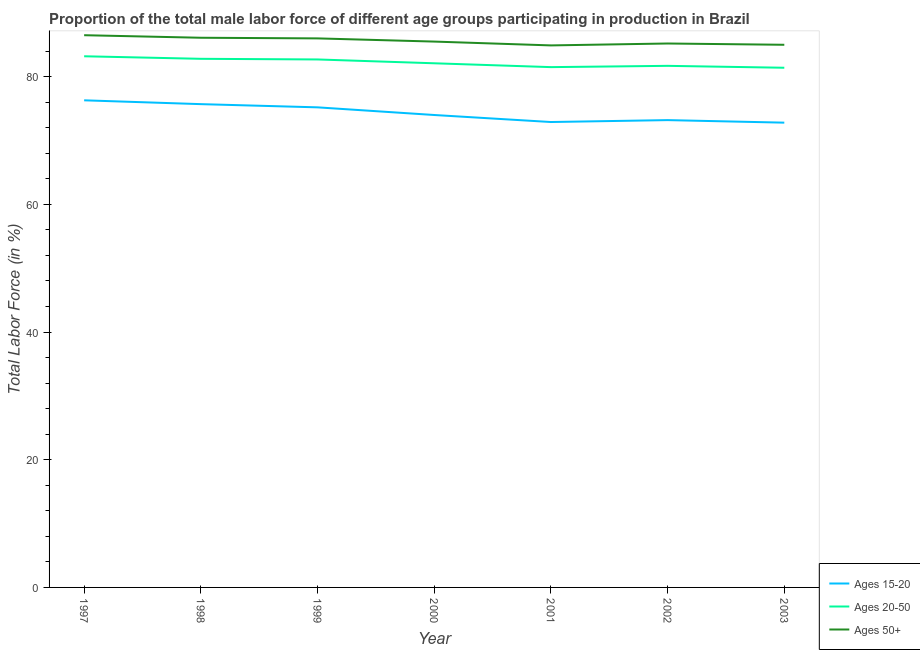Does the line corresponding to percentage of male labor force above age 50 intersect with the line corresponding to percentage of male labor force within the age group 20-50?
Ensure brevity in your answer.  No. What is the percentage of male labor force within the age group 15-20 in 2002?
Make the answer very short. 73.2. Across all years, what is the maximum percentage of male labor force within the age group 20-50?
Make the answer very short. 83.2. Across all years, what is the minimum percentage of male labor force above age 50?
Provide a short and direct response. 84.9. In which year was the percentage of male labor force above age 50 minimum?
Offer a very short reply. 2001. What is the total percentage of male labor force above age 50 in the graph?
Provide a short and direct response. 599.2. What is the difference between the percentage of male labor force within the age group 20-50 in 1997 and that in 1999?
Offer a terse response. 0.5. What is the difference between the percentage of male labor force within the age group 20-50 in 1999 and the percentage of male labor force within the age group 15-20 in 2001?
Your response must be concise. 9.8. What is the average percentage of male labor force above age 50 per year?
Make the answer very short. 85.6. What is the ratio of the percentage of male labor force above age 50 in 1998 to that in 2002?
Make the answer very short. 1.01. Is the difference between the percentage of male labor force above age 50 in 1998 and 2003 greater than the difference between the percentage of male labor force within the age group 15-20 in 1998 and 2003?
Your answer should be compact. No. What is the difference between the highest and the second highest percentage of male labor force above age 50?
Offer a very short reply. 0.4. What is the difference between the highest and the lowest percentage of male labor force within the age group 20-50?
Offer a terse response. 1.8. In how many years, is the percentage of male labor force above age 50 greater than the average percentage of male labor force above age 50 taken over all years?
Make the answer very short. 3. Is the sum of the percentage of male labor force within the age group 15-20 in 2002 and 2003 greater than the maximum percentage of male labor force above age 50 across all years?
Provide a short and direct response. Yes. Does the percentage of male labor force above age 50 monotonically increase over the years?
Your response must be concise. No. What is the difference between two consecutive major ticks on the Y-axis?
Make the answer very short. 20. Are the values on the major ticks of Y-axis written in scientific E-notation?
Give a very brief answer. No. How many legend labels are there?
Ensure brevity in your answer.  3. How are the legend labels stacked?
Keep it short and to the point. Vertical. What is the title of the graph?
Keep it short and to the point. Proportion of the total male labor force of different age groups participating in production in Brazil. Does "Labor Tax" appear as one of the legend labels in the graph?
Offer a very short reply. No. What is the Total Labor Force (in %) of Ages 15-20 in 1997?
Provide a succinct answer. 76.3. What is the Total Labor Force (in %) of Ages 20-50 in 1997?
Ensure brevity in your answer.  83.2. What is the Total Labor Force (in %) of Ages 50+ in 1997?
Give a very brief answer. 86.5. What is the Total Labor Force (in %) in Ages 15-20 in 1998?
Give a very brief answer. 75.7. What is the Total Labor Force (in %) in Ages 20-50 in 1998?
Provide a succinct answer. 82.8. What is the Total Labor Force (in %) of Ages 50+ in 1998?
Your answer should be compact. 86.1. What is the Total Labor Force (in %) in Ages 15-20 in 1999?
Your answer should be compact. 75.2. What is the Total Labor Force (in %) in Ages 20-50 in 1999?
Provide a succinct answer. 82.7. What is the Total Labor Force (in %) of Ages 15-20 in 2000?
Your response must be concise. 74. What is the Total Labor Force (in %) in Ages 20-50 in 2000?
Offer a terse response. 82.1. What is the Total Labor Force (in %) of Ages 50+ in 2000?
Provide a short and direct response. 85.5. What is the Total Labor Force (in %) in Ages 15-20 in 2001?
Give a very brief answer. 72.9. What is the Total Labor Force (in %) of Ages 20-50 in 2001?
Your response must be concise. 81.5. What is the Total Labor Force (in %) of Ages 50+ in 2001?
Provide a short and direct response. 84.9. What is the Total Labor Force (in %) in Ages 15-20 in 2002?
Offer a very short reply. 73.2. What is the Total Labor Force (in %) of Ages 20-50 in 2002?
Ensure brevity in your answer.  81.7. What is the Total Labor Force (in %) in Ages 50+ in 2002?
Provide a succinct answer. 85.2. What is the Total Labor Force (in %) in Ages 15-20 in 2003?
Your response must be concise. 72.8. What is the Total Labor Force (in %) in Ages 20-50 in 2003?
Offer a very short reply. 81.4. What is the Total Labor Force (in %) of Ages 50+ in 2003?
Provide a succinct answer. 85. Across all years, what is the maximum Total Labor Force (in %) of Ages 15-20?
Offer a very short reply. 76.3. Across all years, what is the maximum Total Labor Force (in %) of Ages 20-50?
Provide a short and direct response. 83.2. Across all years, what is the maximum Total Labor Force (in %) in Ages 50+?
Give a very brief answer. 86.5. Across all years, what is the minimum Total Labor Force (in %) of Ages 15-20?
Ensure brevity in your answer.  72.8. Across all years, what is the minimum Total Labor Force (in %) in Ages 20-50?
Ensure brevity in your answer.  81.4. Across all years, what is the minimum Total Labor Force (in %) of Ages 50+?
Ensure brevity in your answer.  84.9. What is the total Total Labor Force (in %) in Ages 15-20 in the graph?
Your answer should be compact. 520.1. What is the total Total Labor Force (in %) in Ages 20-50 in the graph?
Provide a short and direct response. 575.4. What is the total Total Labor Force (in %) in Ages 50+ in the graph?
Your answer should be compact. 599.2. What is the difference between the Total Labor Force (in %) in Ages 15-20 in 1997 and that in 1998?
Provide a short and direct response. 0.6. What is the difference between the Total Labor Force (in %) in Ages 50+ in 1997 and that in 1998?
Offer a very short reply. 0.4. What is the difference between the Total Labor Force (in %) of Ages 20-50 in 1997 and that in 1999?
Give a very brief answer. 0.5. What is the difference between the Total Labor Force (in %) in Ages 50+ in 1997 and that in 1999?
Provide a short and direct response. 0.5. What is the difference between the Total Labor Force (in %) of Ages 15-20 in 1997 and that in 2000?
Keep it short and to the point. 2.3. What is the difference between the Total Labor Force (in %) of Ages 15-20 in 1997 and that in 2001?
Offer a terse response. 3.4. What is the difference between the Total Labor Force (in %) of Ages 50+ in 1997 and that in 2001?
Your answer should be very brief. 1.6. What is the difference between the Total Labor Force (in %) in Ages 15-20 in 1997 and that in 2002?
Provide a short and direct response. 3.1. What is the difference between the Total Labor Force (in %) of Ages 20-50 in 1997 and that in 2002?
Offer a terse response. 1.5. What is the difference between the Total Labor Force (in %) of Ages 50+ in 1997 and that in 2002?
Offer a very short reply. 1.3. What is the difference between the Total Labor Force (in %) in Ages 50+ in 1998 and that in 2000?
Your answer should be compact. 0.6. What is the difference between the Total Labor Force (in %) in Ages 20-50 in 1998 and that in 2001?
Provide a succinct answer. 1.3. What is the difference between the Total Labor Force (in %) of Ages 50+ in 1998 and that in 2001?
Give a very brief answer. 1.2. What is the difference between the Total Labor Force (in %) of Ages 15-20 in 1998 and that in 2002?
Make the answer very short. 2.5. What is the difference between the Total Labor Force (in %) of Ages 20-50 in 1998 and that in 2002?
Provide a short and direct response. 1.1. What is the difference between the Total Labor Force (in %) in Ages 20-50 in 1998 and that in 2003?
Ensure brevity in your answer.  1.4. What is the difference between the Total Labor Force (in %) of Ages 50+ in 1998 and that in 2003?
Make the answer very short. 1.1. What is the difference between the Total Labor Force (in %) in Ages 20-50 in 1999 and that in 2000?
Offer a terse response. 0.6. What is the difference between the Total Labor Force (in %) of Ages 50+ in 1999 and that in 2000?
Give a very brief answer. 0.5. What is the difference between the Total Labor Force (in %) in Ages 20-50 in 1999 and that in 2001?
Your response must be concise. 1.2. What is the difference between the Total Labor Force (in %) in Ages 50+ in 1999 and that in 2001?
Your answer should be very brief. 1.1. What is the difference between the Total Labor Force (in %) of Ages 20-50 in 1999 and that in 2002?
Give a very brief answer. 1. What is the difference between the Total Labor Force (in %) of Ages 50+ in 1999 and that in 2002?
Make the answer very short. 0.8. What is the difference between the Total Labor Force (in %) of Ages 15-20 in 2000 and that in 2001?
Your answer should be very brief. 1.1. What is the difference between the Total Labor Force (in %) in Ages 20-50 in 2000 and that in 2001?
Provide a succinct answer. 0.6. What is the difference between the Total Labor Force (in %) of Ages 50+ in 2000 and that in 2001?
Offer a very short reply. 0.6. What is the difference between the Total Labor Force (in %) of Ages 15-20 in 2000 and that in 2002?
Your answer should be very brief. 0.8. What is the difference between the Total Labor Force (in %) of Ages 50+ in 2000 and that in 2002?
Keep it short and to the point. 0.3. What is the difference between the Total Labor Force (in %) in Ages 15-20 in 2000 and that in 2003?
Offer a terse response. 1.2. What is the difference between the Total Labor Force (in %) of Ages 50+ in 2000 and that in 2003?
Make the answer very short. 0.5. What is the difference between the Total Labor Force (in %) in Ages 50+ in 2001 and that in 2002?
Your answer should be compact. -0.3. What is the difference between the Total Labor Force (in %) in Ages 20-50 in 2001 and that in 2003?
Ensure brevity in your answer.  0.1. What is the difference between the Total Labor Force (in %) of Ages 50+ in 2001 and that in 2003?
Offer a very short reply. -0.1. What is the difference between the Total Labor Force (in %) of Ages 20-50 in 2002 and that in 2003?
Keep it short and to the point. 0.3. What is the difference between the Total Labor Force (in %) of Ages 15-20 in 1997 and the Total Labor Force (in %) of Ages 20-50 in 1998?
Your answer should be compact. -6.5. What is the difference between the Total Labor Force (in %) of Ages 20-50 in 1997 and the Total Labor Force (in %) of Ages 50+ in 1998?
Your answer should be very brief. -2.9. What is the difference between the Total Labor Force (in %) of Ages 15-20 in 1997 and the Total Labor Force (in %) of Ages 20-50 in 1999?
Ensure brevity in your answer.  -6.4. What is the difference between the Total Labor Force (in %) in Ages 15-20 in 1997 and the Total Labor Force (in %) in Ages 50+ in 1999?
Provide a short and direct response. -9.7. What is the difference between the Total Labor Force (in %) in Ages 20-50 in 1997 and the Total Labor Force (in %) in Ages 50+ in 1999?
Offer a very short reply. -2.8. What is the difference between the Total Labor Force (in %) of Ages 20-50 in 1997 and the Total Labor Force (in %) of Ages 50+ in 2000?
Make the answer very short. -2.3. What is the difference between the Total Labor Force (in %) of Ages 15-20 in 1997 and the Total Labor Force (in %) of Ages 20-50 in 2002?
Your response must be concise. -5.4. What is the difference between the Total Labor Force (in %) in Ages 15-20 in 1997 and the Total Labor Force (in %) in Ages 50+ in 2002?
Give a very brief answer. -8.9. What is the difference between the Total Labor Force (in %) of Ages 20-50 in 1997 and the Total Labor Force (in %) of Ages 50+ in 2002?
Your answer should be compact. -2. What is the difference between the Total Labor Force (in %) of Ages 15-20 in 1997 and the Total Labor Force (in %) of Ages 20-50 in 2003?
Offer a very short reply. -5.1. What is the difference between the Total Labor Force (in %) in Ages 15-20 in 1997 and the Total Labor Force (in %) in Ages 50+ in 2003?
Your response must be concise. -8.7. What is the difference between the Total Labor Force (in %) of Ages 20-50 in 1997 and the Total Labor Force (in %) of Ages 50+ in 2003?
Offer a terse response. -1.8. What is the difference between the Total Labor Force (in %) of Ages 15-20 in 1998 and the Total Labor Force (in %) of Ages 20-50 in 1999?
Provide a short and direct response. -7. What is the difference between the Total Labor Force (in %) in Ages 15-20 in 1998 and the Total Labor Force (in %) in Ages 50+ in 1999?
Ensure brevity in your answer.  -10.3. What is the difference between the Total Labor Force (in %) of Ages 20-50 in 1998 and the Total Labor Force (in %) of Ages 50+ in 1999?
Provide a succinct answer. -3.2. What is the difference between the Total Labor Force (in %) of Ages 15-20 in 1998 and the Total Labor Force (in %) of Ages 20-50 in 2000?
Make the answer very short. -6.4. What is the difference between the Total Labor Force (in %) of Ages 15-20 in 1998 and the Total Labor Force (in %) of Ages 50+ in 2000?
Provide a succinct answer. -9.8. What is the difference between the Total Labor Force (in %) of Ages 15-20 in 1998 and the Total Labor Force (in %) of Ages 20-50 in 2001?
Make the answer very short. -5.8. What is the difference between the Total Labor Force (in %) of Ages 15-20 in 1998 and the Total Labor Force (in %) of Ages 50+ in 2001?
Ensure brevity in your answer.  -9.2. What is the difference between the Total Labor Force (in %) in Ages 20-50 in 1998 and the Total Labor Force (in %) in Ages 50+ in 2001?
Offer a terse response. -2.1. What is the difference between the Total Labor Force (in %) in Ages 15-20 in 1998 and the Total Labor Force (in %) in Ages 20-50 in 2003?
Your answer should be compact. -5.7. What is the difference between the Total Labor Force (in %) of Ages 20-50 in 1998 and the Total Labor Force (in %) of Ages 50+ in 2003?
Your answer should be very brief. -2.2. What is the difference between the Total Labor Force (in %) of Ages 15-20 in 1999 and the Total Labor Force (in %) of Ages 20-50 in 2000?
Provide a short and direct response. -6.9. What is the difference between the Total Labor Force (in %) in Ages 15-20 in 1999 and the Total Labor Force (in %) in Ages 50+ in 2000?
Offer a very short reply. -10.3. What is the difference between the Total Labor Force (in %) in Ages 15-20 in 1999 and the Total Labor Force (in %) in Ages 50+ in 2001?
Offer a terse response. -9.7. What is the difference between the Total Labor Force (in %) in Ages 20-50 in 1999 and the Total Labor Force (in %) in Ages 50+ in 2001?
Provide a succinct answer. -2.2. What is the difference between the Total Labor Force (in %) in Ages 15-20 in 1999 and the Total Labor Force (in %) in Ages 50+ in 2002?
Your answer should be very brief. -10. What is the difference between the Total Labor Force (in %) of Ages 20-50 in 1999 and the Total Labor Force (in %) of Ages 50+ in 2002?
Provide a succinct answer. -2.5. What is the difference between the Total Labor Force (in %) of Ages 15-20 in 1999 and the Total Labor Force (in %) of Ages 20-50 in 2003?
Provide a short and direct response. -6.2. What is the difference between the Total Labor Force (in %) of Ages 15-20 in 1999 and the Total Labor Force (in %) of Ages 50+ in 2003?
Your answer should be very brief. -9.8. What is the difference between the Total Labor Force (in %) in Ages 15-20 in 2000 and the Total Labor Force (in %) in Ages 50+ in 2001?
Keep it short and to the point. -10.9. What is the difference between the Total Labor Force (in %) in Ages 20-50 in 2000 and the Total Labor Force (in %) in Ages 50+ in 2001?
Your answer should be very brief. -2.8. What is the difference between the Total Labor Force (in %) in Ages 15-20 in 2000 and the Total Labor Force (in %) in Ages 20-50 in 2002?
Give a very brief answer. -7.7. What is the difference between the Total Labor Force (in %) in Ages 15-20 in 2000 and the Total Labor Force (in %) in Ages 50+ in 2002?
Give a very brief answer. -11.2. What is the difference between the Total Labor Force (in %) in Ages 20-50 in 2000 and the Total Labor Force (in %) in Ages 50+ in 2002?
Make the answer very short. -3.1. What is the difference between the Total Labor Force (in %) of Ages 20-50 in 2000 and the Total Labor Force (in %) of Ages 50+ in 2003?
Your response must be concise. -2.9. What is the difference between the Total Labor Force (in %) of Ages 15-20 in 2001 and the Total Labor Force (in %) of Ages 20-50 in 2002?
Your answer should be compact. -8.8. What is the difference between the Total Labor Force (in %) of Ages 15-20 in 2001 and the Total Labor Force (in %) of Ages 50+ in 2002?
Your response must be concise. -12.3. What is the difference between the Total Labor Force (in %) of Ages 15-20 in 2002 and the Total Labor Force (in %) of Ages 20-50 in 2003?
Provide a succinct answer. -8.2. What is the difference between the Total Labor Force (in %) in Ages 20-50 in 2002 and the Total Labor Force (in %) in Ages 50+ in 2003?
Your response must be concise. -3.3. What is the average Total Labor Force (in %) in Ages 15-20 per year?
Give a very brief answer. 74.3. What is the average Total Labor Force (in %) in Ages 20-50 per year?
Offer a very short reply. 82.2. What is the average Total Labor Force (in %) in Ages 50+ per year?
Your answer should be compact. 85.6. In the year 1997, what is the difference between the Total Labor Force (in %) in Ages 15-20 and Total Labor Force (in %) in Ages 20-50?
Your answer should be compact. -6.9. In the year 1997, what is the difference between the Total Labor Force (in %) in Ages 15-20 and Total Labor Force (in %) in Ages 50+?
Your response must be concise. -10.2. In the year 1997, what is the difference between the Total Labor Force (in %) in Ages 20-50 and Total Labor Force (in %) in Ages 50+?
Keep it short and to the point. -3.3. In the year 1998, what is the difference between the Total Labor Force (in %) of Ages 15-20 and Total Labor Force (in %) of Ages 20-50?
Offer a terse response. -7.1. In the year 1998, what is the difference between the Total Labor Force (in %) in Ages 15-20 and Total Labor Force (in %) in Ages 50+?
Offer a very short reply. -10.4. In the year 1998, what is the difference between the Total Labor Force (in %) of Ages 20-50 and Total Labor Force (in %) of Ages 50+?
Provide a short and direct response. -3.3. In the year 1999, what is the difference between the Total Labor Force (in %) in Ages 15-20 and Total Labor Force (in %) in Ages 20-50?
Offer a terse response. -7.5. In the year 1999, what is the difference between the Total Labor Force (in %) of Ages 15-20 and Total Labor Force (in %) of Ages 50+?
Keep it short and to the point. -10.8. In the year 1999, what is the difference between the Total Labor Force (in %) of Ages 20-50 and Total Labor Force (in %) of Ages 50+?
Offer a very short reply. -3.3. In the year 2000, what is the difference between the Total Labor Force (in %) of Ages 15-20 and Total Labor Force (in %) of Ages 50+?
Your answer should be very brief. -11.5. In the year 2000, what is the difference between the Total Labor Force (in %) of Ages 20-50 and Total Labor Force (in %) of Ages 50+?
Keep it short and to the point. -3.4. In the year 2001, what is the difference between the Total Labor Force (in %) in Ages 15-20 and Total Labor Force (in %) in Ages 20-50?
Make the answer very short. -8.6. In the year 2001, what is the difference between the Total Labor Force (in %) in Ages 20-50 and Total Labor Force (in %) in Ages 50+?
Your response must be concise. -3.4. In the year 2002, what is the difference between the Total Labor Force (in %) in Ages 20-50 and Total Labor Force (in %) in Ages 50+?
Offer a terse response. -3.5. In the year 2003, what is the difference between the Total Labor Force (in %) of Ages 15-20 and Total Labor Force (in %) of Ages 20-50?
Give a very brief answer. -8.6. In the year 2003, what is the difference between the Total Labor Force (in %) in Ages 15-20 and Total Labor Force (in %) in Ages 50+?
Your response must be concise. -12.2. In the year 2003, what is the difference between the Total Labor Force (in %) in Ages 20-50 and Total Labor Force (in %) in Ages 50+?
Provide a succinct answer. -3.6. What is the ratio of the Total Labor Force (in %) in Ages 15-20 in 1997 to that in 1998?
Provide a short and direct response. 1.01. What is the ratio of the Total Labor Force (in %) of Ages 50+ in 1997 to that in 1998?
Your answer should be very brief. 1. What is the ratio of the Total Labor Force (in %) in Ages 15-20 in 1997 to that in 1999?
Your answer should be compact. 1.01. What is the ratio of the Total Labor Force (in %) of Ages 20-50 in 1997 to that in 1999?
Make the answer very short. 1.01. What is the ratio of the Total Labor Force (in %) of Ages 50+ in 1997 to that in 1999?
Give a very brief answer. 1.01. What is the ratio of the Total Labor Force (in %) of Ages 15-20 in 1997 to that in 2000?
Keep it short and to the point. 1.03. What is the ratio of the Total Labor Force (in %) of Ages 20-50 in 1997 to that in 2000?
Provide a short and direct response. 1.01. What is the ratio of the Total Labor Force (in %) in Ages 50+ in 1997 to that in 2000?
Offer a very short reply. 1.01. What is the ratio of the Total Labor Force (in %) in Ages 15-20 in 1997 to that in 2001?
Your answer should be compact. 1.05. What is the ratio of the Total Labor Force (in %) in Ages 20-50 in 1997 to that in 2001?
Your answer should be compact. 1.02. What is the ratio of the Total Labor Force (in %) in Ages 50+ in 1997 to that in 2001?
Provide a short and direct response. 1.02. What is the ratio of the Total Labor Force (in %) of Ages 15-20 in 1997 to that in 2002?
Ensure brevity in your answer.  1.04. What is the ratio of the Total Labor Force (in %) in Ages 20-50 in 1997 to that in 2002?
Provide a short and direct response. 1.02. What is the ratio of the Total Labor Force (in %) in Ages 50+ in 1997 to that in 2002?
Ensure brevity in your answer.  1.02. What is the ratio of the Total Labor Force (in %) in Ages 15-20 in 1997 to that in 2003?
Provide a short and direct response. 1.05. What is the ratio of the Total Labor Force (in %) of Ages 20-50 in 1997 to that in 2003?
Your response must be concise. 1.02. What is the ratio of the Total Labor Force (in %) of Ages 50+ in 1997 to that in 2003?
Your answer should be very brief. 1.02. What is the ratio of the Total Labor Force (in %) in Ages 15-20 in 1998 to that in 1999?
Offer a terse response. 1.01. What is the ratio of the Total Labor Force (in %) in Ages 20-50 in 1998 to that in 1999?
Ensure brevity in your answer.  1. What is the ratio of the Total Labor Force (in %) of Ages 50+ in 1998 to that in 1999?
Offer a very short reply. 1. What is the ratio of the Total Labor Force (in %) of Ages 15-20 in 1998 to that in 2000?
Your answer should be compact. 1.02. What is the ratio of the Total Labor Force (in %) of Ages 20-50 in 1998 to that in 2000?
Make the answer very short. 1.01. What is the ratio of the Total Labor Force (in %) of Ages 50+ in 1998 to that in 2000?
Offer a very short reply. 1.01. What is the ratio of the Total Labor Force (in %) in Ages 15-20 in 1998 to that in 2001?
Give a very brief answer. 1.04. What is the ratio of the Total Labor Force (in %) of Ages 20-50 in 1998 to that in 2001?
Your answer should be very brief. 1.02. What is the ratio of the Total Labor Force (in %) in Ages 50+ in 1998 to that in 2001?
Ensure brevity in your answer.  1.01. What is the ratio of the Total Labor Force (in %) in Ages 15-20 in 1998 to that in 2002?
Offer a terse response. 1.03. What is the ratio of the Total Labor Force (in %) in Ages 20-50 in 1998 to that in 2002?
Keep it short and to the point. 1.01. What is the ratio of the Total Labor Force (in %) of Ages 50+ in 1998 to that in 2002?
Make the answer very short. 1.01. What is the ratio of the Total Labor Force (in %) of Ages 15-20 in 1998 to that in 2003?
Give a very brief answer. 1.04. What is the ratio of the Total Labor Force (in %) of Ages 20-50 in 1998 to that in 2003?
Give a very brief answer. 1.02. What is the ratio of the Total Labor Force (in %) of Ages 50+ in 1998 to that in 2003?
Your answer should be very brief. 1.01. What is the ratio of the Total Labor Force (in %) in Ages 15-20 in 1999 to that in 2000?
Offer a terse response. 1.02. What is the ratio of the Total Labor Force (in %) of Ages 20-50 in 1999 to that in 2000?
Provide a short and direct response. 1.01. What is the ratio of the Total Labor Force (in %) in Ages 50+ in 1999 to that in 2000?
Give a very brief answer. 1.01. What is the ratio of the Total Labor Force (in %) of Ages 15-20 in 1999 to that in 2001?
Provide a short and direct response. 1.03. What is the ratio of the Total Labor Force (in %) in Ages 20-50 in 1999 to that in 2001?
Your response must be concise. 1.01. What is the ratio of the Total Labor Force (in %) in Ages 15-20 in 1999 to that in 2002?
Ensure brevity in your answer.  1.03. What is the ratio of the Total Labor Force (in %) in Ages 20-50 in 1999 to that in 2002?
Give a very brief answer. 1.01. What is the ratio of the Total Labor Force (in %) of Ages 50+ in 1999 to that in 2002?
Your answer should be compact. 1.01. What is the ratio of the Total Labor Force (in %) in Ages 15-20 in 1999 to that in 2003?
Offer a very short reply. 1.03. What is the ratio of the Total Labor Force (in %) of Ages 20-50 in 1999 to that in 2003?
Provide a succinct answer. 1.02. What is the ratio of the Total Labor Force (in %) of Ages 50+ in 1999 to that in 2003?
Your answer should be compact. 1.01. What is the ratio of the Total Labor Force (in %) of Ages 15-20 in 2000 to that in 2001?
Ensure brevity in your answer.  1.02. What is the ratio of the Total Labor Force (in %) of Ages 20-50 in 2000 to that in 2001?
Ensure brevity in your answer.  1.01. What is the ratio of the Total Labor Force (in %) in Ages 50+ in 2000 to that in 2001?
Your answer should be compact. 1.01. What is the ratio of the Total Labor Force (in %) in Ages 15-20 in 2000 to that in 2002?
Give a very brief answer. 1.01. What is the ratio of the Total Labor Force (in %) of Ages 15-20 in 2000 to that in 2003?
Ensure brevity in your answer.  1.02. What is the ratio of the Total Labor Force (in %) of Ages 20-50 in 2000 to that in 2003?
Your response must be concise. 1.01. What is the ratio of the Total Labor Force (in %) in Ages 50+ in 2000 to that in 2003?
Make the answer very short. 1.01. What is the ratio of the Total Labor Force (in %) in Ages 15-20 in 2001 to that in 2002?
Provide a succinct answer. 1. What is the ratio of the Total Labor Force (in %) in Ages 20-50 in 2001 to that in 2002?
Offer a terse response. 1. What is the ratio of the Total Labor Force (in %) of Ages 15-20 in 2001 to that in 2003?
Provide a short and direct response. 1. What is the ratio of the Total Labor Force (in %) of Ages 50+ in 2001 to that in 2003?
Your answer should be very brief. 1. What is the ratio of the Total Labor Force (in %) in Ages 15-20 in 2002 to that in 2003?
Provide a short and direct response. 1.01. What is the ratio of the Total Labor Force (in %) in Ages 50+ in 2002 to that in 2003?
Provide a succinct answer. 1. What is the difference between the highest and the second highest Total Labor Force (in %) of Ages 20-50?
Offer a terse response. 0.4. What is the difference between the highest and the second highest Total Labor Force (in %) of Ages 50+?
Ensure brevity in your answer.  0.4. What is the difference between the highest and the lowest Total Labor Force (in %) of Ages 20-50?
Provide a short and direct response. 1.8. What is the difference between the highest and the lowest Total Labor Force (in %) in Ages 50+?
Your answer should be compact. 1.6. 